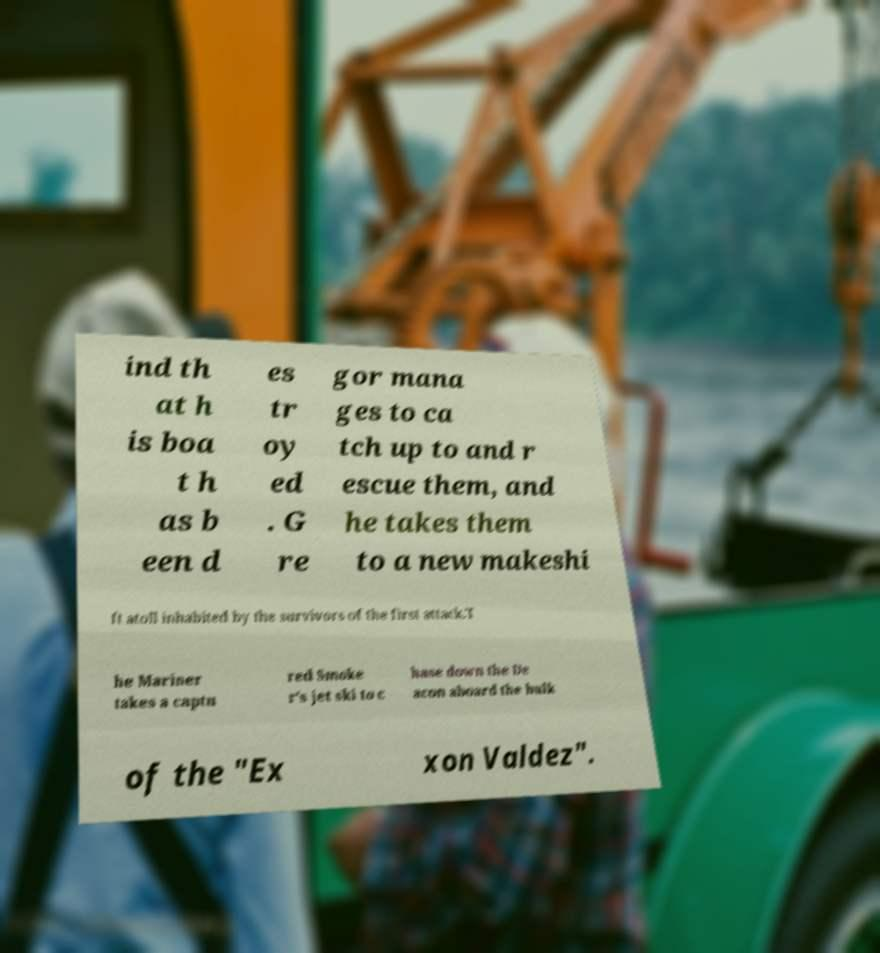Could you assist in decoding the text presented in this image and type it out clearly? ind th at h is boa t h as b een d es tr oy ed . G re gor mana ges to ca tch up to and r escue them, and he takes them to a new makeshi ft atoll inhabited by the survivors of the first attack.T he Mariner takes a captu red Smoke r's jet ski to c hase down the De acon aboard the hulk of the "Ex xon Valdez". 